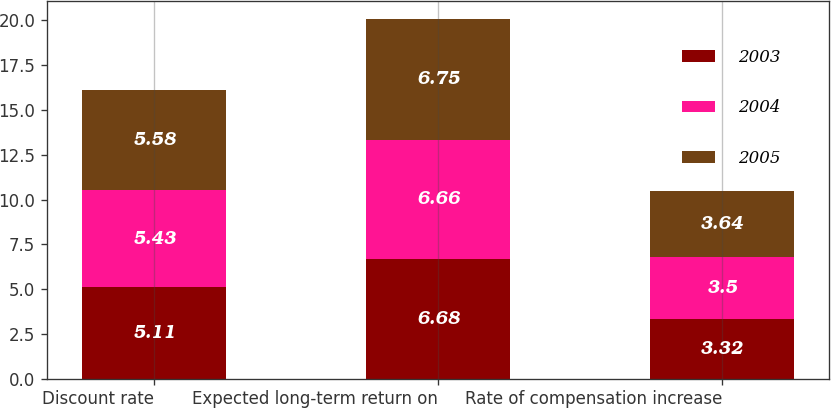Convert chart to OTSL. <chart><loc_0><loc_0><loc_500><loc_500><stacked_bar_chart><ecel><fcel>Discount rate<fcel>Expected long-term return on<fcel>Rate of compensation increase<nl><fcel>2003<fcel>5.11<fcel>6.68<fcel>3.32<nl><fcel>2004<fcel>5.43<fcel>6.66<fcel>3.5<nl><fcel>2005<fcel>5.58<fcel>6.75<fcel>3.64<nl></chart> 